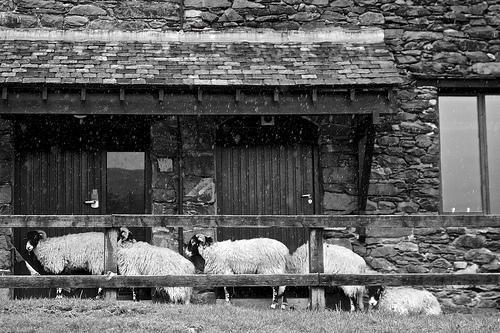How many animals are there?
Give a very brief answer. 5. How many people are in the picture?
Give a very brief answer. 0. 